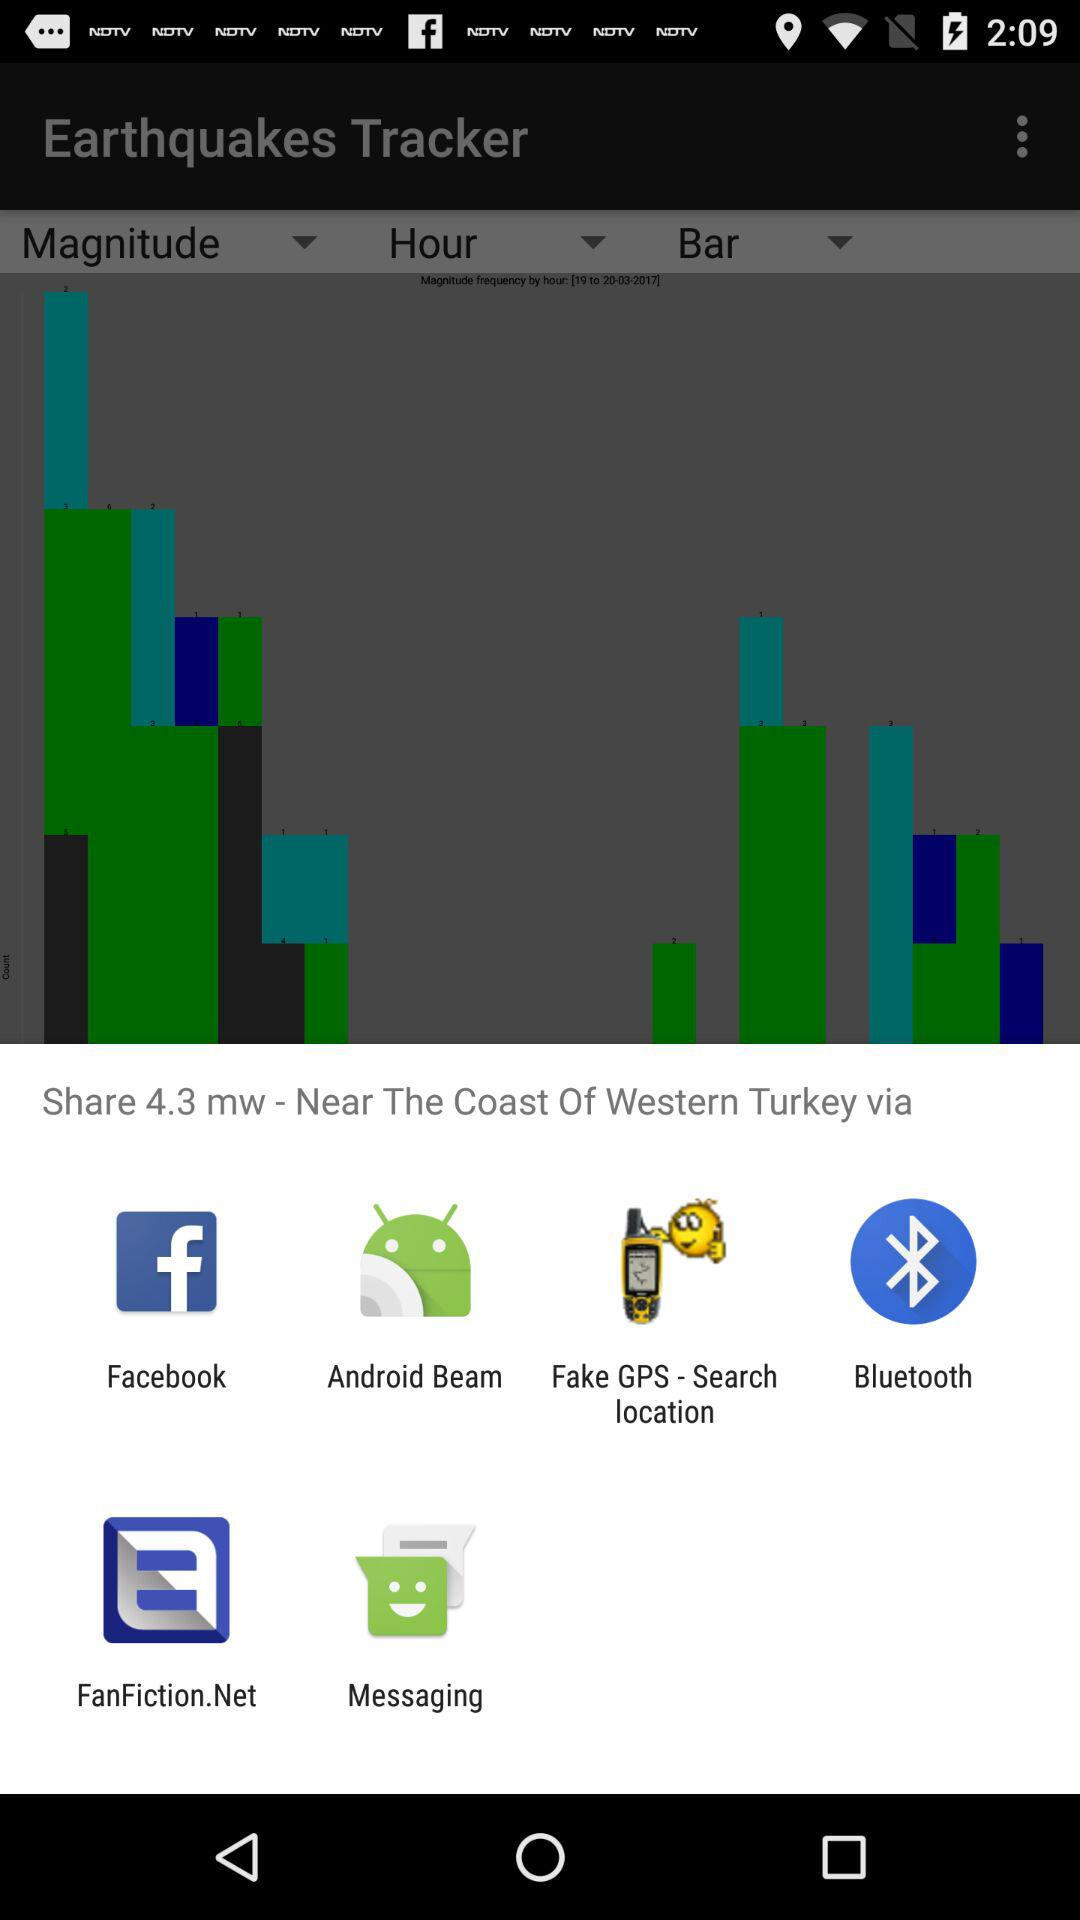Through which application can we share "4.3 mw - Near The Coast Of Western Turkey"? You can share through "Facebook", "Android Beam", "Fake GPS - Search location", "Bluetooth", "FanFiction.Net" and "Messaging". 